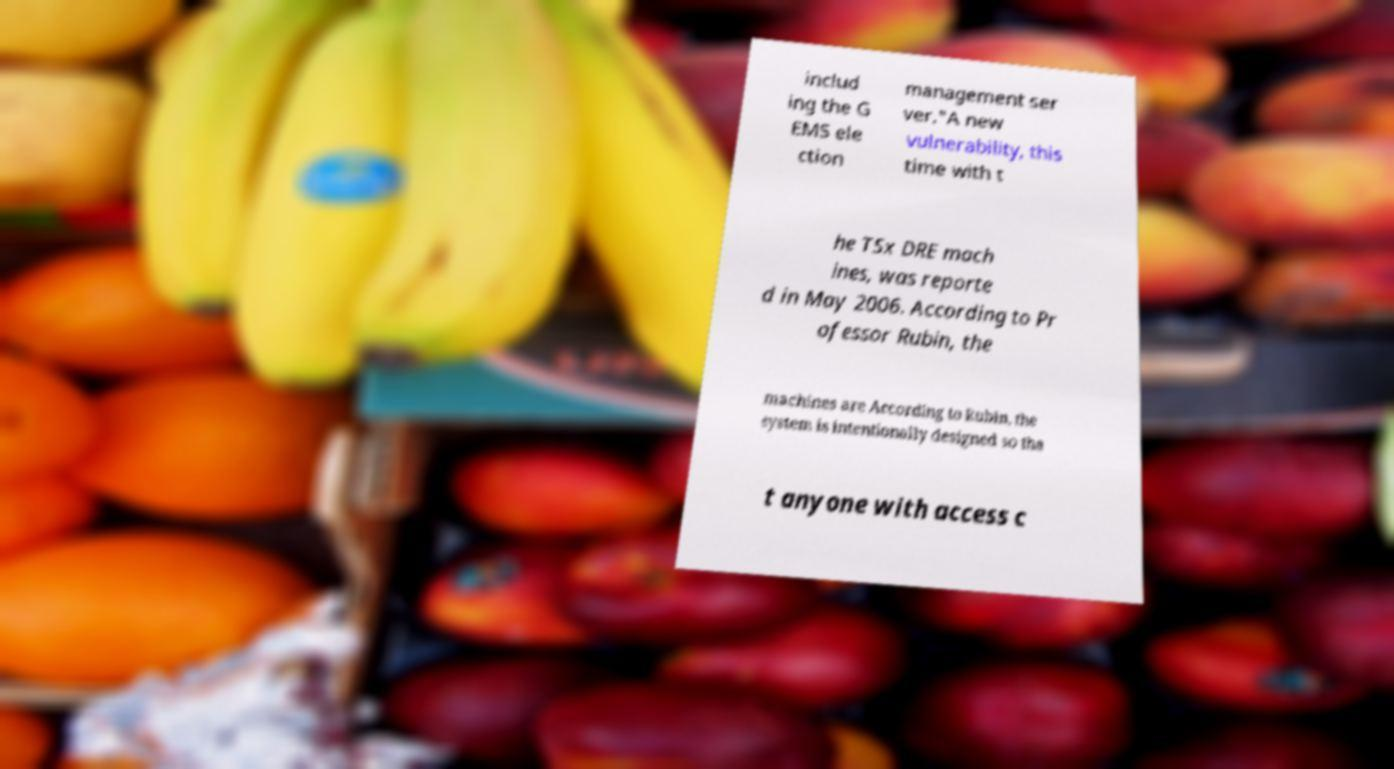Please read and relay the text visible in this image. What does it say? includ ing the G EMS ele ction management ser ver."A new vulnerability, this time with t he TSx DRE mach ines, was reporte d in May 2006. According to Pr ofessor Rubin, the machines are According to Rubin, the system is intentionally designed so tha t anyone with access c 